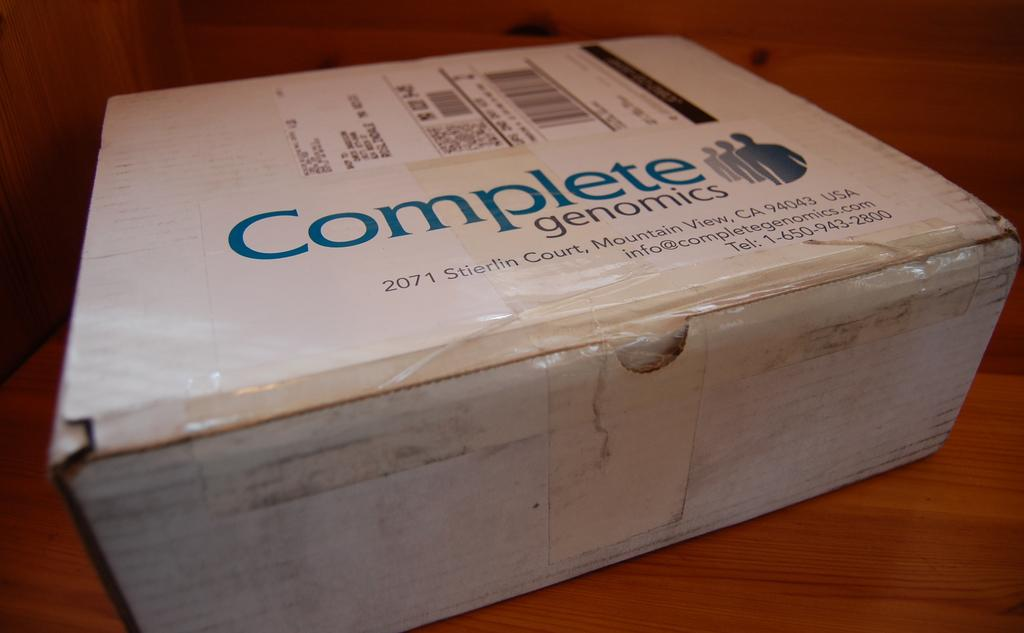<image>
Give a short and clear explanation of the subsequent image. A white cardboard box for the Complete Genomics company. 